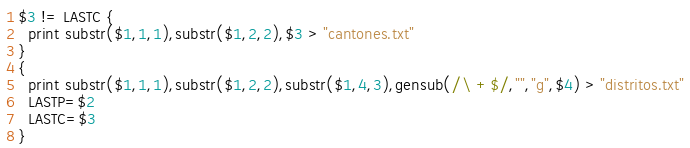<code> <loc_0><loc_0><loc_500><loc_500><_Awk_>$3 != LASTC {
  print substr($1,1,1),substr($1,2,2),$3 > "cantones.txt"
}
{
  print substr($1,1,1),substr($1,2,2),substr($1,4,3),gensub(/\ +$/,"","g",$4) > "distritos.txt"
  LASTP=$2
  LASTC=$3
}
</code> 